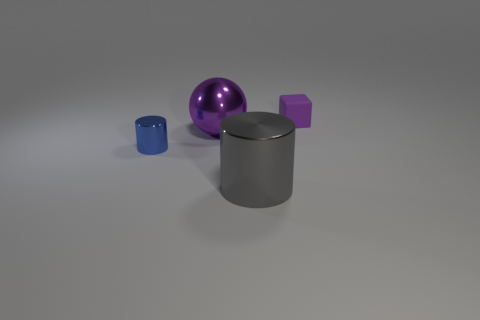Add 3 tiny gray matte things. How many objects exist? 7 Subtract all cubes. How many objects are left? 3 Add 1 purple metal balls. How many purple metal balls are left? 2 Add 4 tiny purple shiny balls. How many tiny purple shiny balls exist? 4 Subtract 0 green cylinders. How many objects are left? 4 Subtract all small purple matte things. Subtract all large purple metallic spheres. How many objects are left? 2 